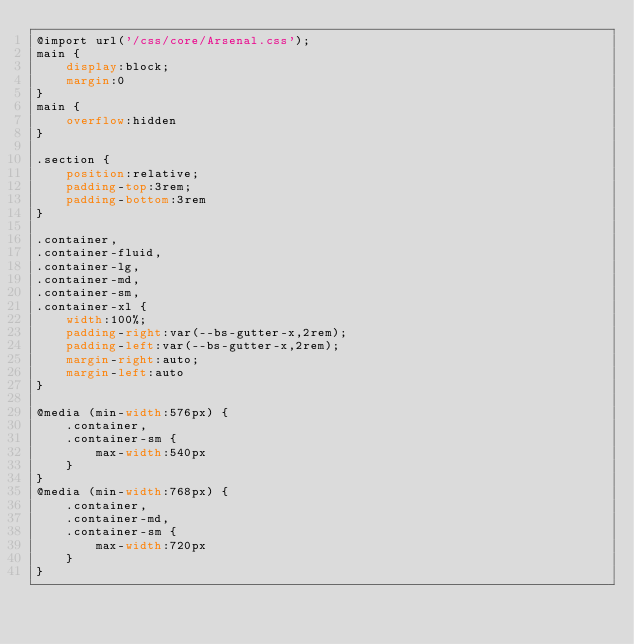Convert code to text. <code><loc_0><loc_0><loc_500><loc_500><_CSS_>@import url('/css/core/Arsenal.css');
main {
    display:block;
    margin:0
}
main {
    overflow:hidden
}

.section {
    position:relative;
    padding-top:3rem;
    padding-bottom:3rem
}

.container,
.container-fluid,
.container-lg,
.container-md,
.container-sm,
.container-xl {
    width:100%;
    padding-right:var(--bs-gutter-x,2rem);
    padding-left:var(--bs-gutter-x,2rem);
    margin-right:auto;
    margin-left:auto
}

@media (min-width:576px) {
    .container,
    .container-sm {
        max-width:540px
    }
}
@media (min-width:768px) {
    .container,
    .container-md,
    .container-sm {
        max-width:720px
    }
}</code> 